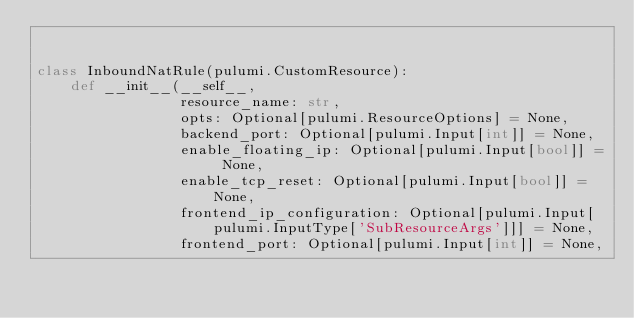<code> <loc_0><loc_0><loc_500><loc_500><_Python_>

class InboundNatRule(pulumi.CustomResource):
    def __init__(__self__,
                 resource_name: str,
                 opts: Optional[pulumi.ResourceOptions] = None,
                 backend_port: Optional[pulumi.Input[int]] = None,
                 enable_floating_ip: Optional[pulumi.Input[bool]] = None,
                 enable_tcp_reset: Optional[pulumi.Input[bool]] = None,
                 frontend_ip_configuration: Optional[pulumi.Input[pulumi.InputType['SubResourceArgs']]] = None,
                 frontend_port: Optional[pulumi.Input[int]] = None,</code> 